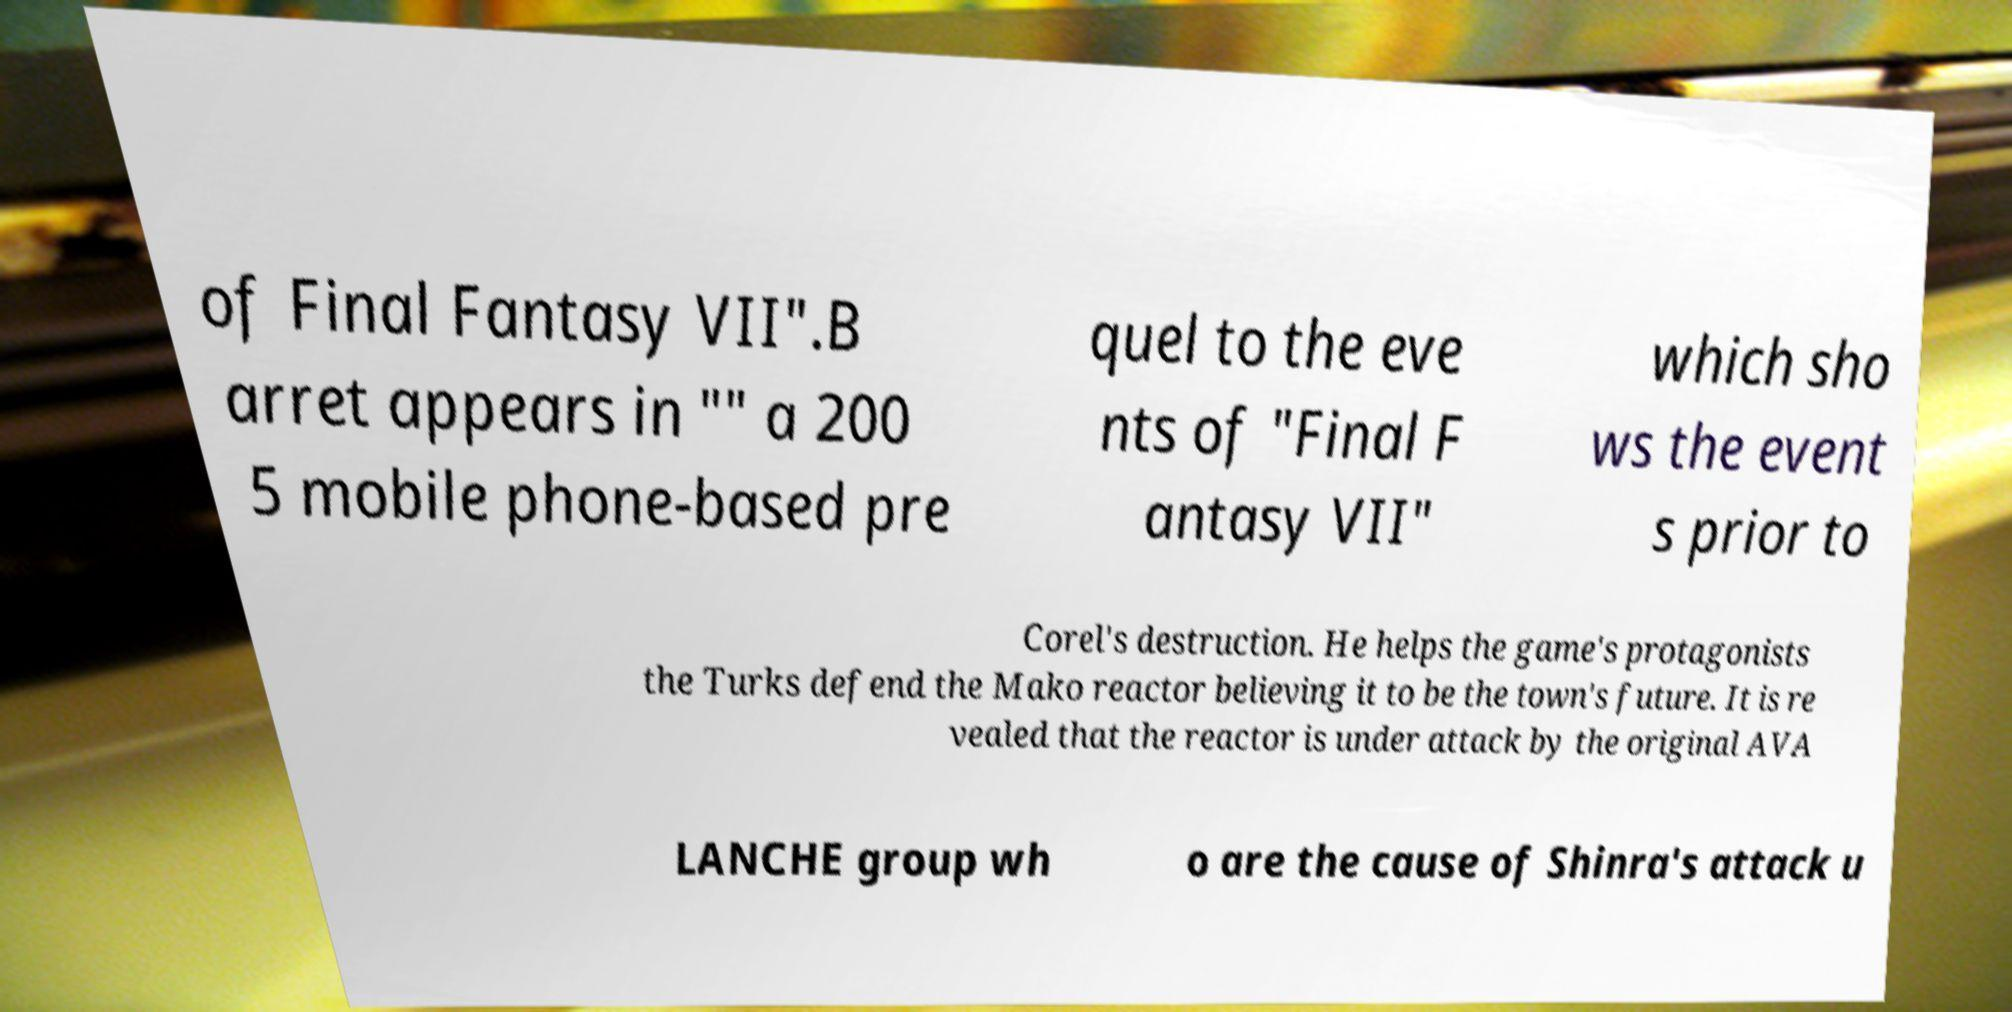What messages or text are displayed in this image? I need them in a readable, typed format. of Final Fantasy VII".B arret appears in "" a 200 5 mobile phone-based pre quel to the eve nts of "Final F antasy VII" which sho ws the event s prior to Corel's destruction. He helps the game's protagonists the Turks defend the Mako reactor believing it to be the town's future. It is re vealed that the reactor is under attack by the original AVA LANCHE group wh o are the cause of Shinra's attack u 